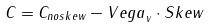Convert formula to latex. <formula><loc_0><loc_0><loc_500><loc_500>C = C _ { n o s k e w } - { V e g a } _ { v } \cdot { S k e w }</formula> 